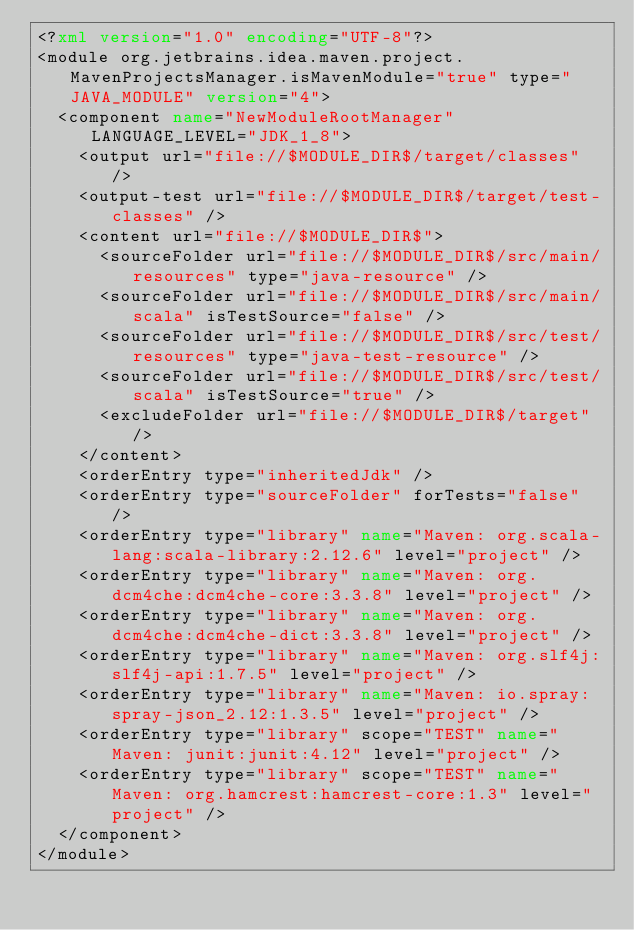Convert code to text. <code><loc_0><loc_0><loc_500><loc_500><_XML_><?xml version="1.0" encoding="UTF-8"?>
<module org.jetbrains.idea.maven.project.MavenProjectsManager.isMavenModule="true" type="JAVA_MODULE" version="4">
  <component name="NewModuleRootManager" LANGUAGE_LEVEL="JDK_1_8">
    <output url="file://$MODULE_DIR$/target/classes" />
    <output-test url="file://$MODULE_DIR$/target/test-classes" />
    <content url="file://$MODULE_DIR$">
      <sourceFolder url="file://$MODULE_DIR$/src/main/resources" type="java-resource" />
      <sourceFolder url="file://$MODULE_DIR$/src/main/scala" isTestSource="false" />
      <sourceFolder url="file://$MODULE_DIR$/src/test/resources" type="java-test-resource" />
      <sourceFolder url="file://$MODULE_DIR$/src/test/scala" isTestSource="true" />
      <excludeFolder url="file://$MODULE_DIR$/target" />
    </content>
    <orderEntry type="inheritedJdk" />
    <orderEntry type="sourceFolder" forTests="false" />
    <orderEntry type="library" name="Maven: org.scala-lang:scala-library:2.12.6" level="project" />
    <orderEntry type="library" name="Maven: org.dcm4che:dcm4che-core:3.3.8" level="project" />
    <orderEntry type="library" name="Maven: org.dcm4che:dcm4che-dict:3.3.8" level="project" />
    <orderEntry type="library" name="Maven: org.slf4j:slf4j-api:1.7.5" level="project" />
    <orderEntry type="library" name="Maven: io.spray:spray-json_2.12:1.3.5" level="project" />
    <orderEntry type="library" scope="TEST" name="Maven: junit:junit:4.12" level="project" />
    <orderEntry type="library" scope="TEST" name="Maven: org.hamcrest:hamcrest-core:1.3" level="project" />
  </component>
</module></code> 